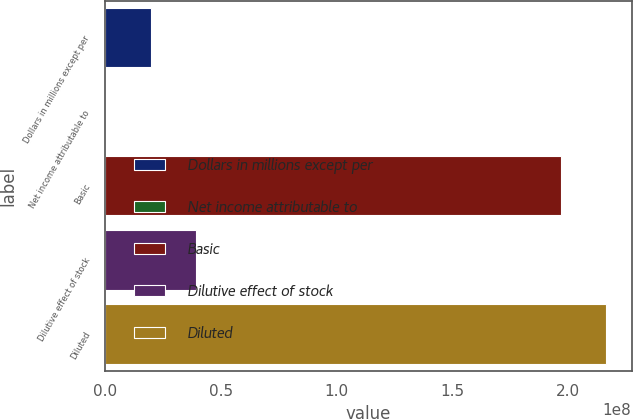Convert chart to OTSL. <chart><loc_0><loc_0><loc_500><loc_500><bar_chart><fcel>Dollars in millions except per<fcel>Net income attributable to<fcel>Basic<fcel>Dilutive effect of stock<fcel>Diluted<nl><fcel>1.97158e+07<fcel>1040<fcel>1.96699e+08<fcel>3.94305e+07<fcel>2.16414e+08<nl></chart> 